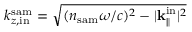<formula> <loc_0><loc_0><loc_500><loc_500>k _ { z , i n } ^ { s a m } = \sqrt { ( n _ { s a m } \omega / c ) ^ { 2 } - | { k } _ { \| } ^ { i n } | ^ { 2 } }</formula> 